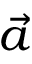<formula> <loc_0><loc_0><loc_500><loc_500>\vec { a }</formula> 